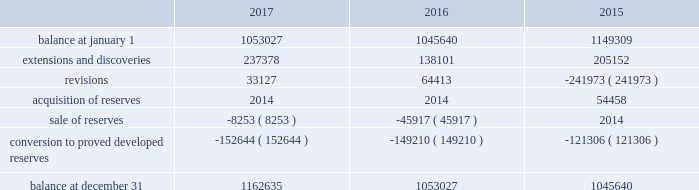Eog resources , inc .
Supplemental information to consolidated financial statements ( continued ) net proved undeveloped reserves .
The table presents the changes in eog's total proved undeveloped reserves during 2017 , 2016 and 2015 ( in mboe ) : .
For the twelve-month period ended december 31 , 2017 , total puds increased by 110 mmboe to 1163 mmboe .
Eog added approximately 38 mmboe of puds through drilling activities where the wells were drilled but significant expenditures remained for completion .
Based on the technology employed by eog to identify and record puds ( see discussion of technology employed on pages f-38 and f-39 of this annual report on form 10-k ) , eog added 199 mmboe .
The pud additions were primarily in the permian basin and , to a lesser extent , the eagle ford and the rocky mountain area , and 74% ( 74 % ) of the additions were crude oil and condensate and ngls .
During 2017 , eog drilled and transferred 153 mmboe of puds to proved developed reserves at a total capital cost of $ 1440 million .
Revisions of puds totaled positive 33 mmboe , primarily due to updated type curves resulting from improved performance of offsetting wells in the permian basin , the impact of increases in the average crude oil and natural gas prices used in the december 31 , 2017 , reserves estimation as compared to the prices used in the prior year estimate , and lower costs .
During 2017 , eog sold or exchanged 8 mmboe of puds primarily in the permian basin .
All puds , including drilled but uncompleted wells ( ducs ) , are scheduled for completion within five years of the original reserve booking .
For the twelve-month period ended december 31 , 2016 , total puds increased by 7 mmboe to 1053 mmboe .
Eog added approximately 21 mmboe of puds through drilling activities where the wells were drilled but significant expenditures remained for completion .
Based on the technology employed by eog to identify and record puds , eog added 117 mmboe .
The pud additions were primarily in the permian basin and , to a lesser extent , the rocky mountain area , and 82% ( 82 % ) of the additions were crude oil and condensate and ngls .
During 2016 , eog drilled and transferred 149 mmboe of puds to proved developed reserves at a total capital cost of $ 1230 million .
Revisions of puds totaled positive 64 mmboe , primarily due to improved well performance , primarily in the delaware basin , and lower production costs , partially offset by the impact of decreases in the average crude oil and natural gas prices used in the december 31 , 2016 , reserves estimation as compared to the prices used in the prior year estimate .
During 2016 , eog sold 46 mmboe of puds primarily in the haynesville play .
All puds for drilled but uncompleted wells ( ducs ) are scheduled for completion within five years of the original reserve booking .
For the twelve-month period ended december 31 , 2015 , total puds decreased by 104 mmboe to 1046 mmboe .
Eog added approximately 52 mmboe of puds through drilling activities where the wells were drilled but significant expenditures remained for completion .
Based on the technology employed by eog to identify and record puds , eog added 153 mmboe .
The pud additions were primarily in the permian basin and , to a lesser extent , the eagle ford and the rocky mountain area , and 80% ( 80 % ) of the additions were crude oil and condensate and ngls .
During 2015 , eog drilled and transferred 121 mmboe of puds to proved developed reserves at a total capital cost of $ 2349 million .
Revisions of puds totaled negative 242 mmboe , primarily due to decreases in the average crude oil and natural gas prices used in the december 31 , 2015 , reserves estimation as compared to the prices used in the prior year estimate .
During 2015 , eog did not sell any puds and acquired 54 mmboe of puds. .
Considering the twelve months ended december 31 , 2017 , what was the percentual increase observed in total puds? 
Rationale: it is the total pud of 1163 mmboe at the end of the period divided by the initial one ( 110 mmboe ) , then subtracted 1 and turned into a percentage .
Computations: ((1163 / 110) - 1)
Answer: 9.57273. 